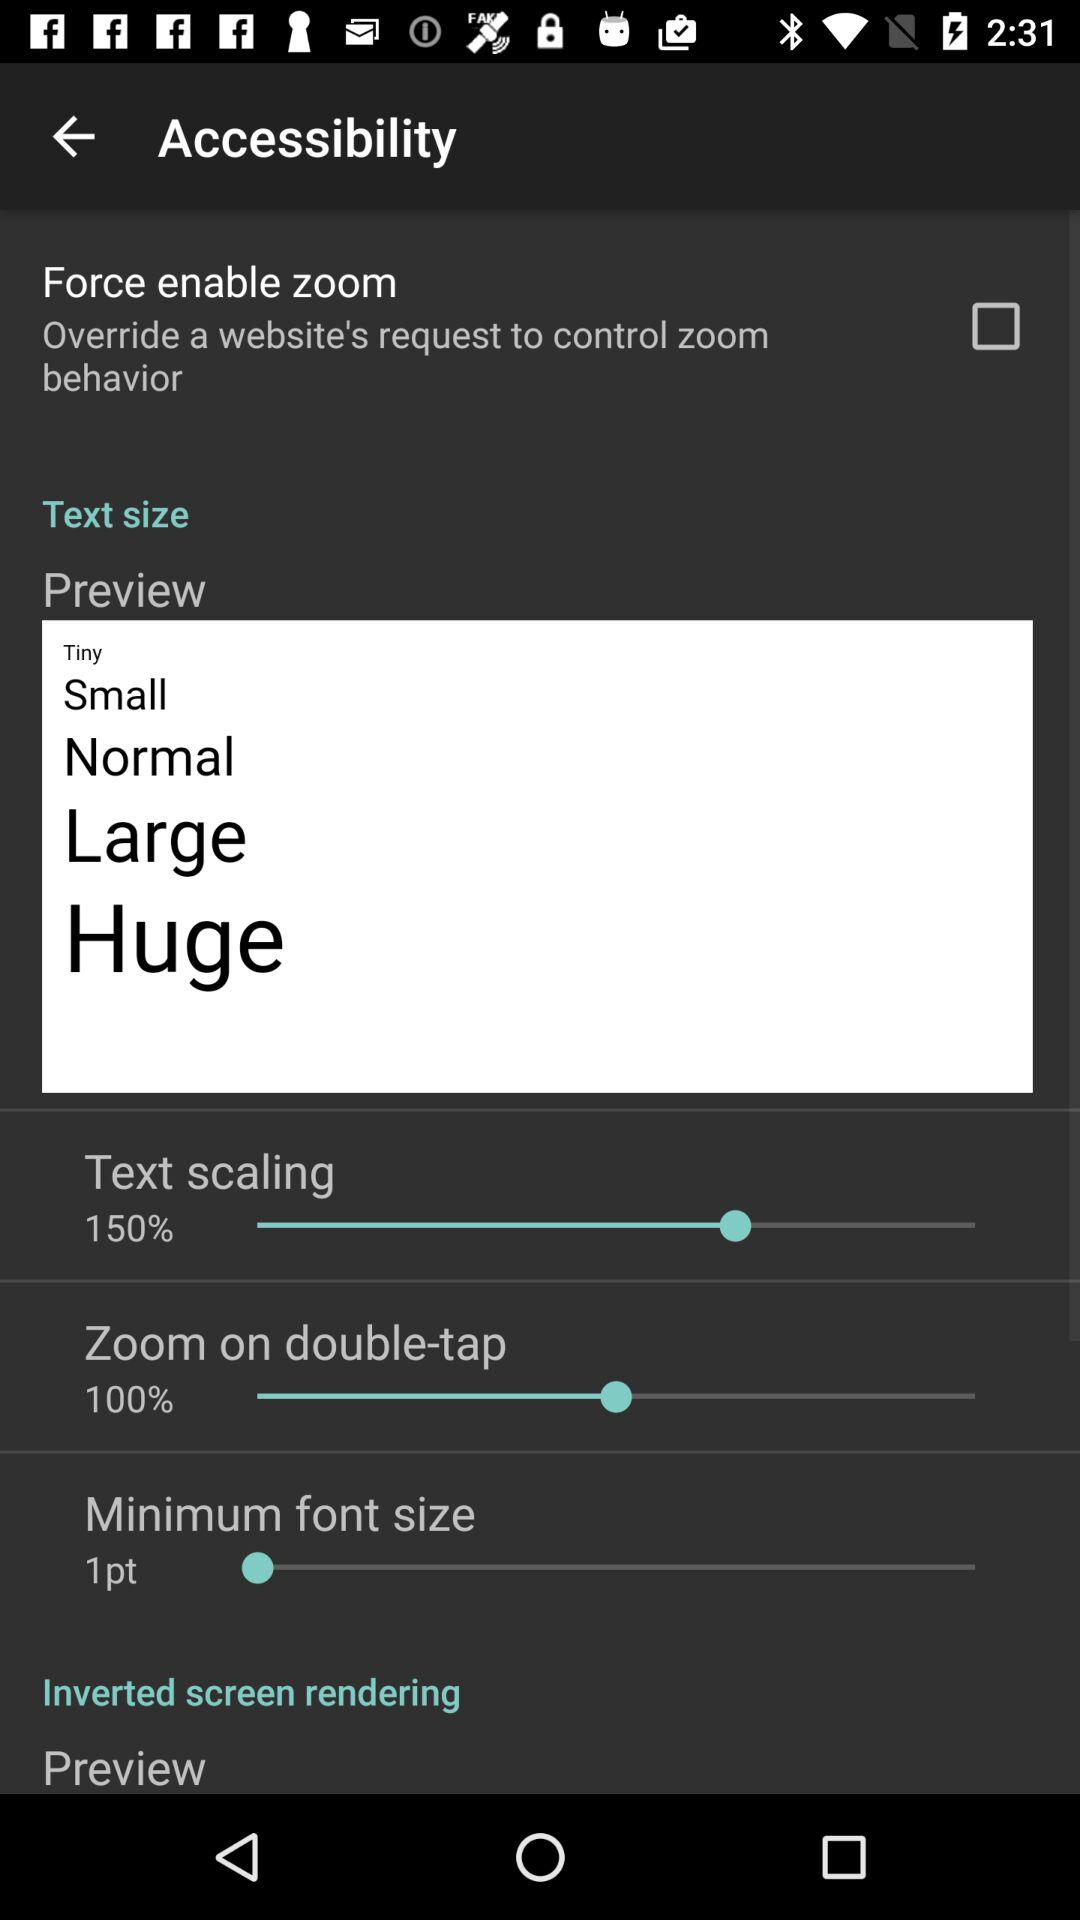What is the percentage of text scaling? The percentage of text scaling is 150. 